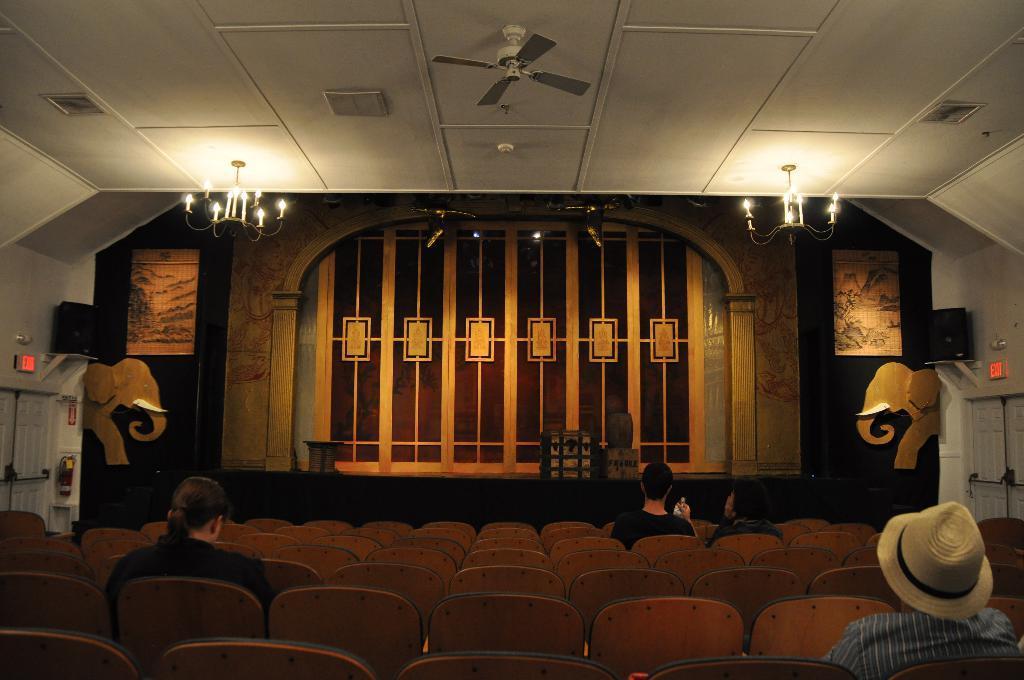How would you summarize this image in a sentence or two? In this image we can see inside of an auditorium. There are few lights and a fan attached to the roof in the image. There are few objects on the walls at the either sides of the image. There are few objects placed on the stage. There are few people sitting on the chairs. 